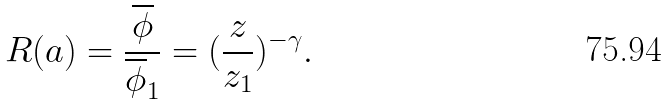Convert formula to latex. <formula><loc_0><loc_0><loc_500><loc_500>R ( a ) = \frac { \overline { \phi } } { \overline { \phi } _ { 1 } } = ( \frac { z } { z _ { 1 } } ) ^ { - \gamma } .</formula> 